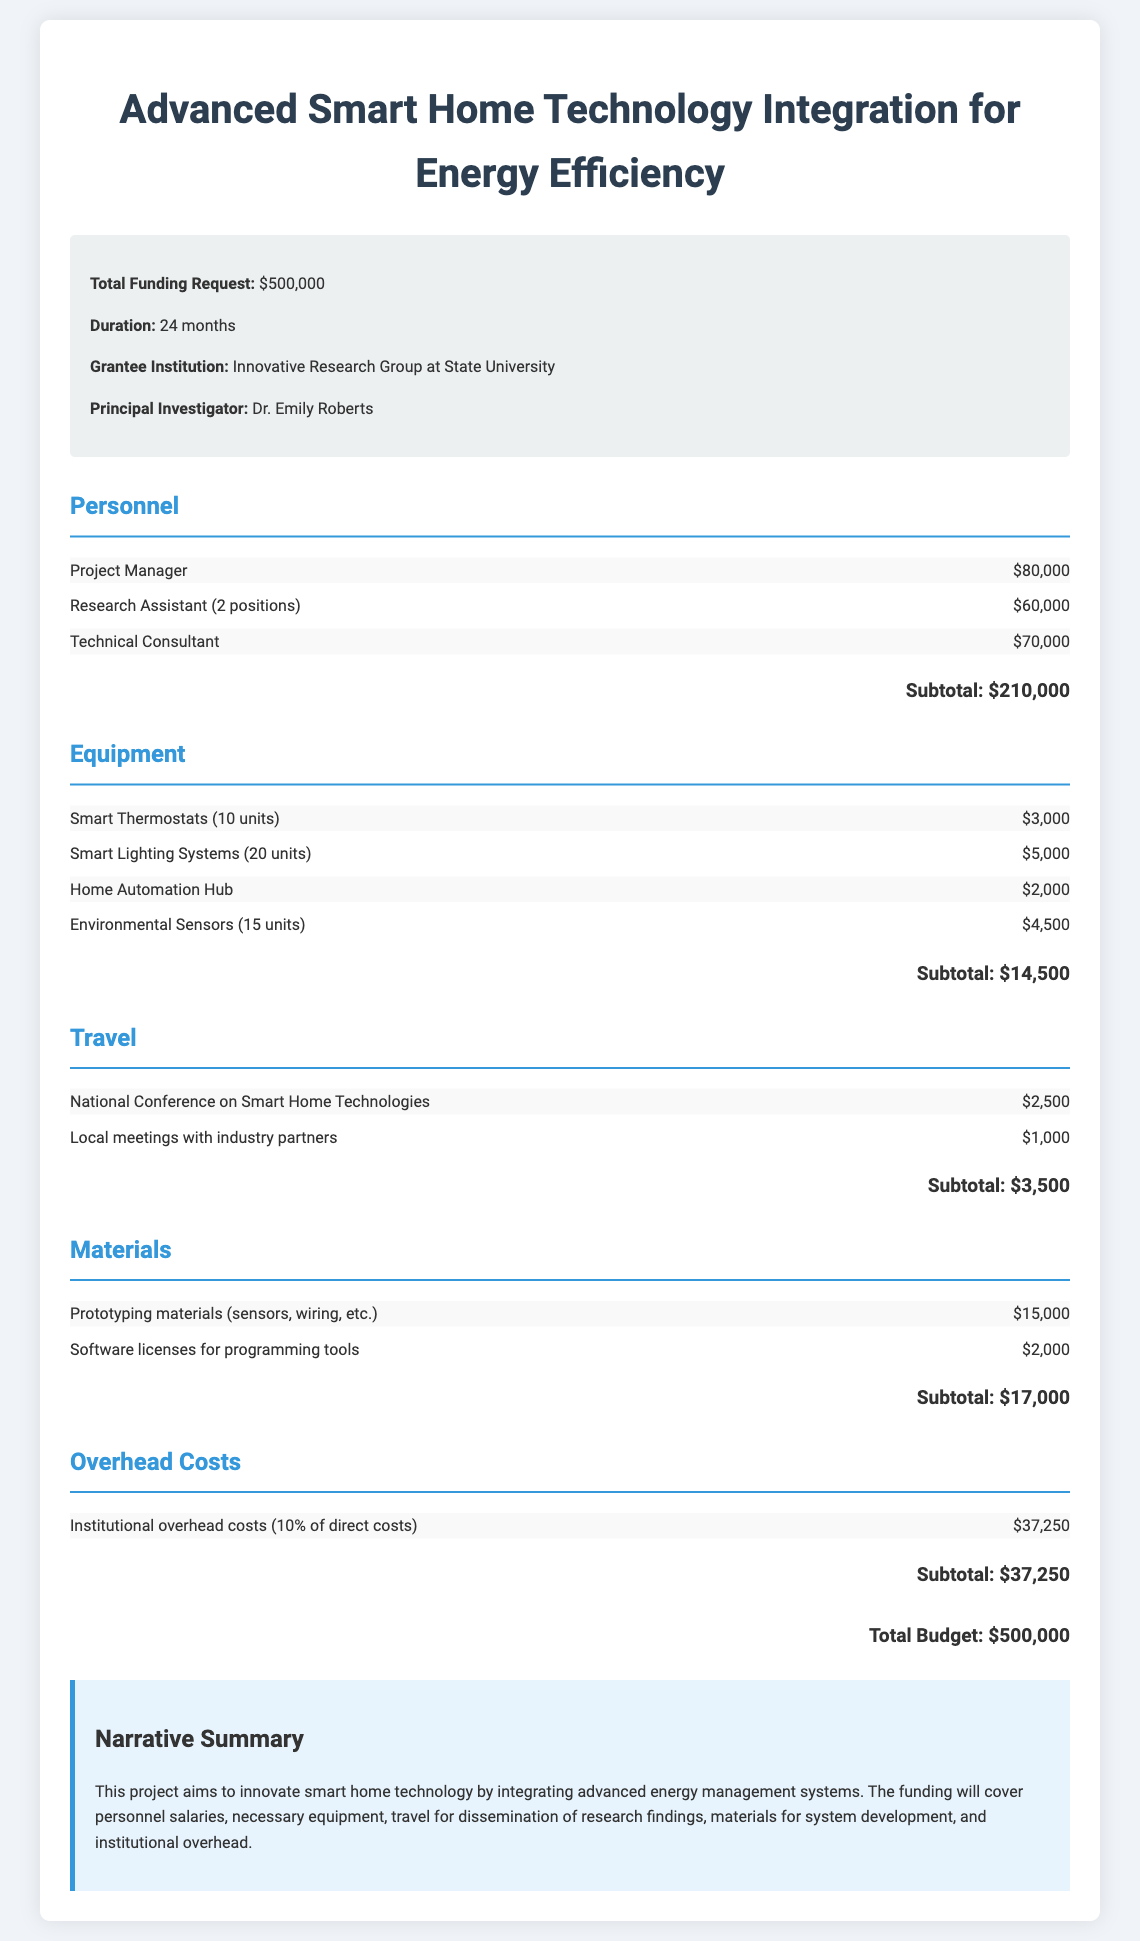What is the total funding request? The total funding request is prominently mentioned in the document, which is $500,000.
Answer: $500,000 Who is the Principal Investigator? The Principal Investigator's name is listed in the grant information section. The name is Dr. Emily Roberts.
Answer: Dr. Emily Roberts How many Research Assistants are proposed in the budget? The budget indicates that there are 2 positions for Research Assistants as part of the personnel costs.
Answer: 2 positions What is the subtotal for Equipment? The subtotal for Equipment is calculated by summing the costs listed under this category, which totals $14,500.
Answer: $14,500 What is the duration of the project? The project duration is specified in the grant information section and is listed as 24 months.
Answer: 24 months What percentage of direct costs is allocated to overhead? The document indicates that overhead costs are calculated as 10% of direct costs.
Answer: 10% What is included in the travel budget? The travel budget includes expenses for a national conference and local meetings with industry partners.
Answer: National Conference on Smart Home Technologies and local meetings What are the materials budgeted for prototyping? The materials budget includes prototyping materials such as sensors and wiring as part of this category.
Answer: Prototyping materials (sensors, wiring, etc.) What is the total budget amount stated in the document? The total budget amount is specifically stated at the end of the document, which is $500,000.
Answer: $500,000 